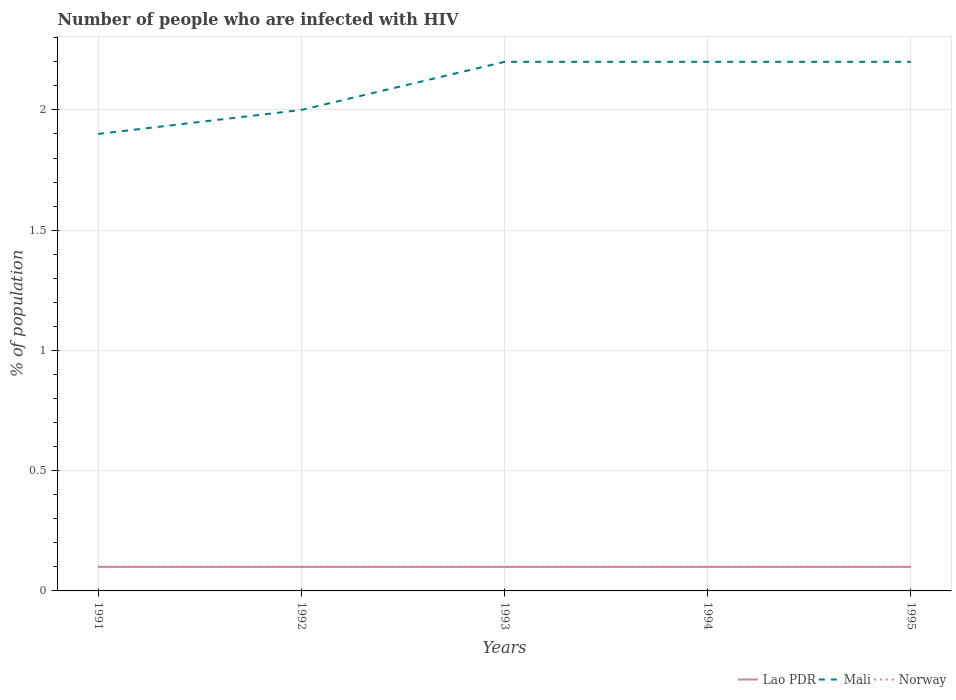How many different coloured lines are there?
Your answer should be compact. 3. Does the line corresponding to Norway intersect with the line corresponding to Lao PDR?
Offer a terse response. Yes. Is the number of lines equal to the number of legend labels?
Provide a short and direct response. Yes. What is the total percentage of HIV infected population in in Mali in the graph?
Your answer should be compact. -0.3. What is the difference between the highest and the second highest percentage of HIV infected population in in Lao PDR?
Make the answer very short. 0. What is the difference between the highest and the lowest percentage of HIV infected population in in Norway?
Provide a short and direct response. 0. Is the percentage of HIV infected population in in Mali strictly greater than the percentage of HIV infected population in in Norway over the years?
Offer a very short reply. No. How many lines are there?
Offer a terse response. 3. What is the difference between two consecutive major ticks on the Y-axis?
Offer a terse response. 0.5. Are the values on the major ticks of Y-axis written in scientific E-notation?
Your response must be concise. No. Where does the legend appear in the graph?
Give a very brief answer. Bottom right. How many legend labels are there?
Give a very brief answer. 3. What is the title of the graph?
Give a very brief answer. Number of people who are infected with HIV. What is the label or title of the Y-axis?
Give a very brief answer. % of population. What is the % of population of Lao PDR in 1992?
Make the answer very short. 0.1. What is the % of population of Norway in 1992?
Ensure brevity in your answer.  0.1. What is the % of population of Mali in 1993?
Keep it short and to the point. 2.2. What is the % of population of Norway in 1993?
Make the answer very short. 0.1. What is the % of population in Lao PDR in 1994?
Provide a succinct answer. 0.1. What is the % of population in Mali in 1994?
Your response must be concise. 2.2. What is the % of population in Norway in 1994?
Offer a very short reply. 0.1. What is the % of population of Lao PDR in 1995?
Your answer should be compact. 0.1. Across all years, what is the maximum % of population of Mali?
Provide a succinct answer. 2.2. Across all years, what is the minimum % of population in Norway?
Keep it short and to the point. 0.1. What is the total % of population of Lao PDR in the graph?
Keep it short and to the point. 0.5. What is the difference between the % of population of Mali in 1991 and that in 1992?
Provide a short and direct response. -0.1. What is the difference between the % of population of Norway in 1991 and that in 1992?
Keep it short and to the point. 0. What is the difference between the % of population in Norway in 1991 and that in 1993?
Give a very brief answer. 0. What is the difference between the % of population in Lao PDR in 1991 and that in 1995?
Offer a terse response. 0. What is the difference between the % of population in Lao PDR in 1992 and that in 1993?
Your answer should be compact. 0. What is the difference between the % of population of Norway in 1992 and that in 1993?
Your answer should be very brief. 0. What is the difference between the % of population of Lao PDR in 1992 and that in 1994?
Give a very brief answer. 0. What is the difference between the % of population of Mali in 1992 and that in 1994?
Your answer should be very brief. -0.2. What is the difference between the % of population of Lao PDR in 1992 and that in 1995?
Your response must be concise. 0. What is the difference between the % of population of Mali in 1992 and that in 1995?
Your response must be concise. -0.2. What is the difference between the % of population in Norway in 1992 and that in 1995?
Make the answer very short. 0. What is the difference between the % of population in Lao PDR in 1993 and that in 1994?
Provide a short and direct response. 0. What is the difference between the % of population of Mali in 1993 and that in 1994?
Your answer should be compact. 0. What is the difference between the % of population of Norway in 1993 and that in 1994?
Give a very brief answer. 0. What is the difference between the % of population in Lao PDR in 1993 and that in 1995?
Your answer should be compact. 0. What is the difference between the % of population in Mali in 1994 and that in 1995?
Provide a succinct answer. 0. What is the difference between the % of population in Norway in 1994 and that in 1995?
Your answer should be compact. 0. What is the difference between the % of population in Lao PDR in 1991 and the % of population in Norway in 1992?
Offer a very short reply. 0. What is the difference between the % of population in Mali in 1991 and the % of population in Norway in 1992?
Offer a terse response. 1.8. What is the difference between the % of population in Lao PDR in 1991 and the % of population in Norway in 1993?
Ensure brevity in your answer.  0. What is the difference between the % of population in Lao PDR in 1991 and the % of population in Norway in 1995?
Provide a short and direct response. 0. What is the difference between the % of population in Lao PDR in 1992 and the % of population in Mali in 1993?
Offer a very short reply. -2.1. What is the difference between the % of population in Mali in 1992 and the % of population in Norway in 1994?
Your answer should be very brief. 1.9. What is the difference between the % of population in Lao PDR in 1992 and the % of population in Mali in 1995?
Your response must be concise. -2.1. What is the difference between the % of population of Mali in 1992 and the % of population of Norway in 1995?
Your answer should be very brief. 1.9. What is the difference between the % of population of Lao PDR in 1993 and the % of population of Norway in 1994?
Offer a very short reply. 0. What is the difference between the % of population of Mali in 1993 and the % of population of Norway in 1994?
Your answer should be compact. 2.1. What is the difference between the % of population in Lao PDR in 1993 and the % of population in Mali in 1995?
Ensure brevity in your answer.  -2.1. What is the difference between the % of population in Mali in 1993 and the % of population in Norway in 1995?
Provide a short and direct response. 2.1. What is the difference between the % of population in Lao PDR in 1994 and the % of population in Mali in 1995?
Make the answer very short. -2.1. What is the average % of population in Lao PDR per year?
Give a very brief answer. 0.1. What is the average % of population of Mali per year?
Provide a short and direct response. 2.1. What is the average % of population in Norway per year?
Your answer should be compact. 0.1. In the year 1991, what is the difference between the % of population of Lao PDR and % of population of Mali?
Provide a succinct answer. -1.8. In the year 1991, what is the difference between the % of population in Lao PDR and % of population in Norway?
Your response must be concise. 0. In the year 1991, what is the difference between the % of population in Mali and % of population in Norway?
Ensure brevity in your answer.  1.8. In the year 1993, what is the difference between the % of population in Lao PDR and % of population in Mali?
Make the answer very short. -2.1. In the year 1993, what is the difference between the % of population in Mali and % of population in Norway?
Your answer should be compact. 2.1. In the year 1994, what is the difference between the % of population in Lao PDR and % of population in Norway?
Provide a succinct answer. 0. In the year 1994, what is the difference between the % of population of Mali and % of population of Norway?
Provide a succinct answer. 2.1. In the year 1995, what is the difference between the % of population of Mali and % of population of Norway?
Your answer should be compact. 2.1. What is the ratio of the % of population in Lao PDR in 1991 to that in 1992?
Make the answer very short. 1. What is the ratio of the % of population in Norway in 1991 to that in 1992?
Offer a terse response. 1. What is the ratio of the % of population of Mali in 1991 to that in 1993?
Your answer should be compact. 0.86. What is the ratio of the % of population of Norway in 1991 to that in 1993?
Ensure brevity in your answer.  1. What is the ratio of the % of population in Mali in 1991 to that in 1994?
Your answer should be very brief. 0.86. What is the ratio of the % of population in Lao PDR in 1991 to that in 1995?
Provide a short and direct response. 1. What is the ratio of the % of population of Mali in 1991 to that in 1995?
Provide a short and direct response. 0.86. What is the ratio of the % of population in Mali in 1992 to that in 1993?
Offer a terse response. 0.91. What is the ratio of the % of population of Lao PDR in 1992 to that in 1994?
Your response must be concise. 1. What is the ratio of the % of population in Lao PDR in 1992 to that in 1995?
Provide a succinct answer. 1. What is the ratio of the % of population in Mali in 1992 to that in 1995?
Provide a succinct answer. 0.91. What is the ratio of the % of population of Norway in 1992 to that in 1995?
Provide a succinct answer. 1. What is the ratio of the % of population of Lao PDR in 1993 to that in 1994?
Give a very brief answer. 1. What is the ratio of the % of population of Mali in 1993 to that in 1994?
Give a very brief answer. 1. What is the ratio of the % of population in Norway in 1993 to that in 1994?
Offer a very short reply. 1. What is the ratio of the % of population of Mali in 1993 to that in 1995?
Keep it short and to the point. 1. What is the ratio of the % of population of Norway in 1993 to that in 1995?
Your answer should be compact. 1. What is the difference between the highest and the lowest % of population of Mali?
Provide a succinct answer. 0.3. 